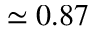Convert formula to latex. <formula><loc_0><loc_0><loc_500><loc_500>\simeq 0 . 8 7</formula> 